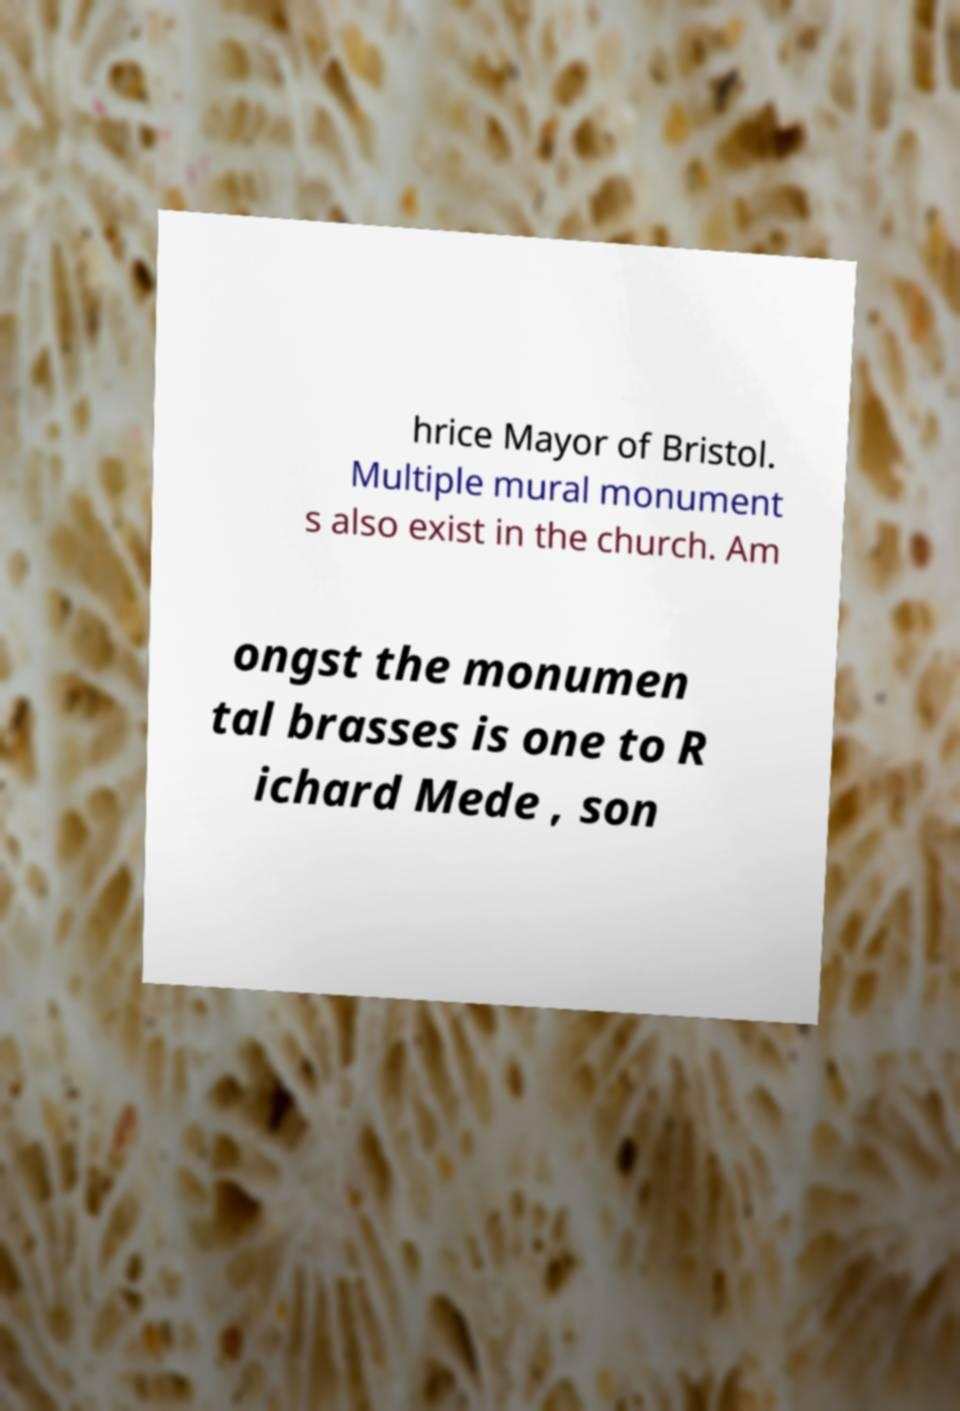What messages or text are displayed in this image? I need them in a readable, typed format. hrice Mayor of Bristol. Multiple mural monument s also exist in the church. Am ongst the monumen tal brasses is one to R ichard Mede , son 